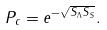<formula> <loc_0><loc_0><loc_500><loc_500>P _ { c } = e ^ { - \sqrt { S _ { \Lambda } S _ { S } } } .</formula> 